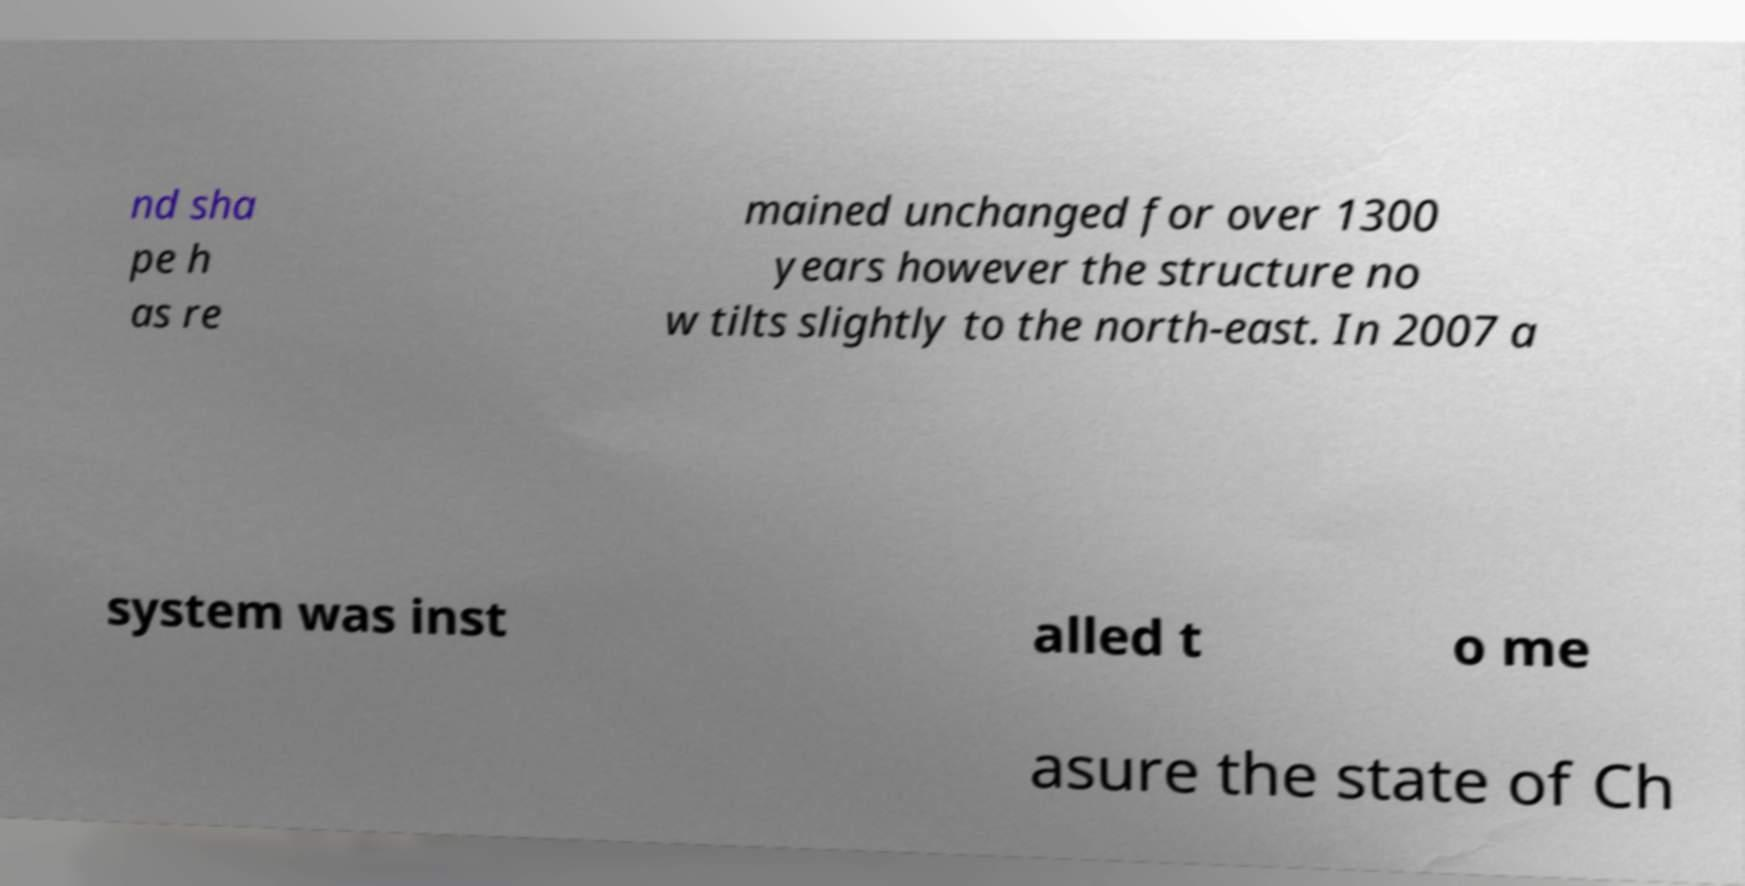What messages or text are displayed in this image? I need them in a readable, typed format. nd sha pe h as re mained unchanged for over 1300 years however the structure no w tilts slightly to the north-east. In 2007 a system was inst alled t o me asure the state of Ch 